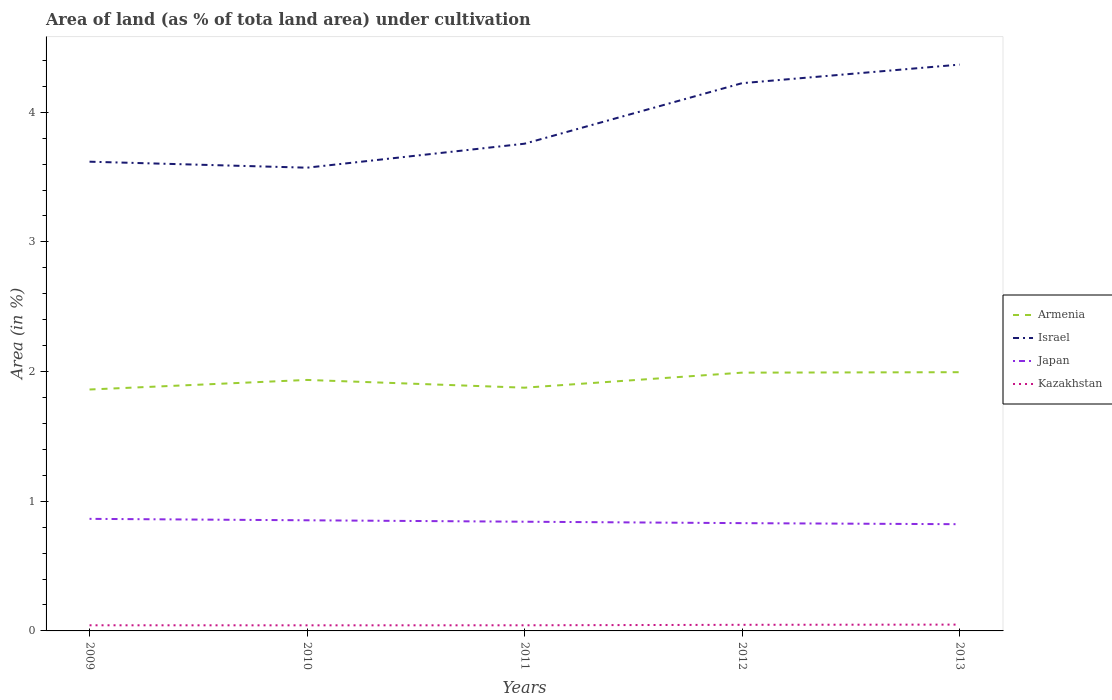Across all years, what is the maximum percentage of land under cultivation in Armenia?
Offer a terse response. 1.86. What is the total percentage of land under cultivation in Israel in the graph?
Provide a short and direct response. -0.61. What is the difference between the highest and the second highest percentage of land under cultivation in Japan?
Make the answer very short. 0.04. What is the difference between two consecutive major ticks on the Y-axis?
Offer a very short reply. 1. Are the values on the major ticks of Y-axis written in scientific E-notation?
Your answer should be compact. No. Does the graph contain any zero values?
Offer a very short reply. No. Does the graph contain grids?
Offer a terse response. No. How many legend labels are there?
Give a very brief answer. 4. What is the title of the graph?
Provide a short and direct response. Area of land (as % of tota land area) under cultivation. Does "United Arab Emirates" appear as one of the legend labels in the graph?
Your response must be concise. No. What is the label or title of the X-axis?
Your response must be concise. Years. What is the label or title of the Y-axis?
Your answer should be compact. Area (in %). What is the Area (in %) in Armenia in 2009?
Offer a very short reply. 1.86. What is the Area (in %) of Israel in 2009?
Give a very brief answer. 3.62. What is the Area (in %) in Japan in 2009?
Your answer should be compact. 0.86. What is the Area (in %) in Kazakhstan in 2009?
Offer a terse response. 0.04. What is the Area (in %) in Armenia in 2010?
Offer a terse response. 1.94. What is the Area (in %) in Israel in 2010?
Keep it short and to the point. 3.57. What is the Area (in %) in Japan in 2010?
Your answer should be compact. 0.85. What is the Area (in %) in Kazakhstan in 2010?
Your answer should be compact. 0.04. What is the Area (in %) in Armenia in 2011?
Your response must be concise. 1.88. What is the Area (in %) of Israel in 2011?
Ensure brevity in your answer.  3.76. What is the Area (in %) in Japan in 2011?
Provide a short and direct response. 0.84. What is the Area (in %) in Kazakhstan in 2011?
Provide a succinct answer. 0.04. What is the Area (in %) of Armenia in 2012?
Offer a terse response. 1.99. What is the Area (in %) in Israel in 2012?
Your response must be concise. 4.22. What is the Area (in %) of Japan in 2012?
Offer a terse response. 0.83. What is the Area (in %) in Kazakhstan in 2012?
Provide a succinct answer. 0.05. What is the Area (in %) in Armenia in 2013?
Ensure brevity in your answer.  2. What is the Area (in %) of Israel in 2013?
Provide a succinct answer. 4.37. What is the Area (in %) in Japan in 2013?
Provide a succinct answer. 0.82. What is the Area (in %) in Kazakhstan in 2013?
Provide a succinct answer. 0.05. Across all years, what is the maximum Area (in %) in Armenia?
Your answer should be compact. 2. Across all years, what is the maximum Area (in %) in Israel?
Make the answer very short. 4.37. Across all years, what is the maximum Area (in %) in Japan?
Keep it short and to the point. 0.86. Across all years, what is the maximum Area (in %) of Kazakhstan?
Your answer should be compact. 0.05. Across all years, what is the minimum Area (in %) of Armenia?
Keep it short and to the point. 1.86. Across all years, what is the minimum Area (in %) in Israel?
Keep it short and to the point. 3.57. Across all years, what is the minimum Area (in %) in Japan?
Ensure brevity in your answer.  0.82. Across all years, what is the minimum Area (in %) of Kazakhstan?
Your response must be concise. 0.04. What is the total Area (in %) in Armenia in the graph?
Your response must be concise. 9.66. What is the total Area (in %) in Israel in the graph?
Make the answer very short. 19.54. What is the total Area (in %) in Japan in the graph?
Provide a short and direct response. 4.21. What is the total Area (in %) of Kazakhstan in the graph?
Offer a terse response. 0.23. What is the difference between the Area (in %) of Armenia in 2009 and that in 2010?
Ensure brevity in your answer.  -0.07. What is the difference between the Area (in %) of Israel in 2009 and that in 2010?
Your response must be concise. 0.05. What is the difference between the Area (in %) of Japan in 2009 and that in 2010?
Offer a terse response. 0.01. What is the difference between the Area (in %) of Armenia in 2009 and that in 2011?
Provide a succinct answer. -0.01. What is the difference between the Area (in %) of Israel in 2009 and that in 2011?
Your answer should be very brief. -0.14. What is the difference between the Area (in %) in Japan in 2009 and that in 2011?
Offer a very short reply. 0.02. What is the difference between the Area (in %) in Kazakhstan in 2009 and that in 2011?
Offer a terse response. 0. What is the difference between the Area (in %) in Armenia in 2009 and that in 2012?
Provide a short and direct response. -0.13. What is the difference between the Area (in %) in Israel in 2009 and that in 2012?
Ensure brevity in your answer.  -0.61. What is the difference between the Area (in %) in Japan in 2009 and that in 2012?
Your answer should be very brief. 0.03. What is the difference between the Area (in %) of Kazakhstan in 2009 and that in 2012?
Offer a very short reply. -0. What is the difference between the Area (in %) in Armenia in 2009 and that in 2013?
Provide a short and direct response. -0.13. What is the difference between the Area (in %) in Israel in 2009 and that in 2013?
Make the answer very short. -0.75. What is the difference between the Area (in %) of Japan in 2009 and that in 2013?
Provide a short and direct response. 0.04. What is the difference between the Area (in %) in Kazakhstan in 2009 and that in 2013?
Provide a succinct answer. -0.01. What is the difference between the Area (in %) of Armenia in 2010 and that in 2011?
Offer a terse response. 0.06. What is the difference between the Area (in %) in Israel in 2010 and that in 2011?
Offer a terse response. -0.18. What is the difference between the Area (in %) in Japan in 2010 and that in 2011?
Your answer should be very brief. 0.01. What is the difference between the Area (in %) of Kazakhstan in 2010 and that in 2011?
Your answer should be compact. -0. What is the difference between the Area (in %) of Armenia in 2010 and that in 2012?
Ensure brevity in your answer.  -0.06. What is the difference between the Area (in %) of Israel in 2010 and that in 2012?
Keep it short and to the point. -0.65. What is the difference between the Area (in %) in Japan in 2010 and that in 2012?
Keep it short and to the point. 0.02. What is the difference between the Area (in %) in Kazakhstan in 2010 and that in 2012?
Keep it short and to the point. -0. What is the difference between the Area (in %) of Armenia in 2010 and that in 2013?
Your answer should be compact. -0.06. What is the difference between the Area (in %) in Israel in 2010 and that in 2013?
Your answer should be very brief. -0.79. What is the difference between the Area (in %) of Japan in 2010 and that in 2013?
Ensure brevity in your answer.  0.03. What is the difference between the Area (in %) of Kazakhstan in 2010 and that in 2013?
Offer a very short reply. -0.01. What is the difference between the Area (in %) in Armenia in 2011 and that in 2012?
Keep it short and to the point. -0.12. What is the difference between the Area (in %) of Israel in 2011 and that in 2012?
Provide a short and direct response. -0.47. What is the difference between the Area (in %) in Japan in 2011 and that in 2012?
Provide a short and direct response. 0.01. What is the difference between the Area (in %) in Kazakhstan in 2011 and that in 2012?
Offer a very short reply. -0. What is the difference between the Area (in %) in Armenia in 2011 and that in 2013?
Make the answer very short. -0.12. What is the difference between the Area (in %) in Israel in 2011 and that in 2013?
Offer a terse response. -0.61. What is the difference between the Area (in %) of Japan in 2011 and that in 2013?
Give a very brief answer. 0.02. What is the difference between the Area (in %) in Kazakhstan in 2011 and that in 2013?
Your answer should be compact. -0.01. What is the difference between the Area (in %) in Armenia in 2012 and that in 2013?
Provide a short and direct response. -0. What is the difference between the Area (in %) in Israel in 2012 and that in 2013?
Your answer should be compact. -0.14. What is the difference between the Area (in %) of Japan in 2012 and that in 2013?
Give a very brief answer. 0.01. What is the difference between the Area (in %) of Kazakhstan in 2012 and that in 2013?
Offer a very short reply. -0. What is the difference between the Area (in %) of Armenia in 2009 and the Area (in %) of Israel in 2010?
Offer a terse response. -1.71. What is the difference between the Area (in %) of Armenia in 2009 and the Area (in %) of Japan in 2010?
Provide a succinct answer. 1.01. What is the difference between the Area (in %) of Armenia in 2009 and the Area (in %) of Kazakhstan in 2010?
Ensure brevity in your answer.  1.82. What is the difference between the Area (in %) in Israel in 2009 and the Area (in %) in Japan in 2010?
Give a very brief answer. 2.77. What is the difference between the Area (in %) in Israel in 2009 and the Area (in %) in Kazakhstan in 2010?
Offer a very short reply. 3.58. What is the difference between the Area (in %) in Japan in 2009 and the Area (in %) in Kazakhstan in 2010?
Keep it short and to the point. 0.82. What is the difference between the Area (in %) of Armenia in 2009 and the Area (in %) of Israel in 2011?
Provide a succinct answer. -1.9. What is the difference between the Area (in %) of Armenia in 2009 and the Area (in %) of Japan in 2011?
Keep it short and to the point. 1.02. What is the difference between the Area (in %) of Armenia in 2009 and the Area (in %) of Kazakhstan in 2011?
Your answer should be very brief. 1.82. What is the difference between the Area (in %) in Israel in 2009 and the Area (in %) in Japan in 2011?
Your answer should be very brief. 2.78. What is the difference between the Area (in %) of Israel in 2009 and the Area (in %) of Kazakhstan in 2011?
Your answer should be compact. 3.57. What is the difference between the Area (in %) in Japan in 2009 and the Area (in %) in Kazakhstan in 2011?
Your answer should be very brief. 0.82. What is the difference between the Area (in %) of Armenia in 2009 and the Area (in %) of Israel in 2012?
Provide a succinct answer. -2.36. What is the difference between the Area (in %) in Armenia in 2009 and the Area (in %) in Japan in 2012?
Ensure brevity in your answer.  1.03. What is the difference between the Area (in %) of Armenia in 2009 and the Area (in %) of Kazakhstan in 2012?
Offer a terse response. 1.81. What is the difference between the Area (in %) in Israel in 2009 and the Area (in %) in Japan in 2012?
Keep it short and to the point. 2.79. What is the difference between the Area (in %) in Israel in 2009 and the Area (in %) in Kazakhstan in 2012?
Ensure brevity in your answer.  3.57. What is the difference between the Area (in %) of Japan in 2009 and the Area (in %) of Kazakhstan in 2012?
Give a very brief answer. 0.82. What is the difference between the Area (in %) in Armenia in 2009 and the Area (in %) in Israel in 2013?
Ensure brevity in your answer.  -2.51. What is the difference between the Area (in %) in Armenia in 2009 and the Area (in %) in Japan in 2013?
Provide a short and direct response. 1.04. What is the difference between the Area (in %) of Armenia in 2009 and the Area (in %) of Kazakhstan in 2013?
Your response must be concise. 1.81. What is the difference between the Area (in %) in Israel in 2009 and the Area (in %) in Japan in 2013?
Ensure brevity in your answer.  2.8. What is the difference between the Area (in %) in Israel in 2009 and the Area (in %) in Kazakhstan in 2013?
Provide a short and direct response. 3.57. What is the difference between the Area (in %) of Japan in 2009 and the Area (in %) of Kazakhstan in 2013?
Your answer should be compact. 0.82. What is the difference between the Area (in %) in Armenia in 2010 and the Area (in %) in Israel in 2011?
Your answer should be very brief. -1.82. What is the difference between the Area (in %) of Armenia in 2010 and the Area (in %) of Japan in 2011?
Offer a terse response. 1.09. What is the difference between the Area (in %) of Armenia in 2010 and the Area (in %) of Kazakhstan in 2011?
Your answer should be compact. 1.89. What is the difference between the Area (in %) in Israel in 2010 and the Area (in %) in Japan in 2011?
Offer a terse response. 2.73. What is the difference between the Area (in %) of Israel in 2010 and the Area (in %) of Kazakhstan in 2011?
Make the answer very short. 3.53. What is the difference between the Area (in %) in Japan in 2010 and the Area (in %) in Kazakhstan in 2011?
Offer a terse response. 0.81. What is the difference between the Area (in %) in Armenia in 2010 and the Area (in %) in Israel in 2012?
Your answer should be compact. -2.29. What is the difference between the Area (in %) of Armenia in 2010 and the Area (in %) of Japan in 2012?
Offer a very short reply. 1.1. What is the difference between the Area (in %) in Armenia in 2010 and the Area (in %) in Kazakhstan in 2012?
Give a very brief answer. 1.89. What is the difference between the Area (in %) of Israel in 2010 and the Area (in %) of Japan in 2012?
Give a very brief answer. 2.74. What is the difference between the Area (in %) of Israel in 2010 and the Area (in %) of Kazakhstan in 2012?
Give a very brief answer. 3.52. What is the difference between the Area (in %) of Japan in 2010 and the Area (in %) of Kazakhstan in 2012?
Provide a succinct answer. 0.81. What is the difference between the Area (in %) of Armenia in 2010 and the Area (in %) of Israel in 2013?
Make the answer very short. -2.43. What is the difference between the Area (in %) in Armenia in 2010 and the Area (in %) in Japan in 2013?
Offer a very short reply. 1.11. What is the difference between the Area (in %) of Armenia in 2010 and the Area (in %) of Kazakhstan in 2013?
Keep it short and to the point. 1.89. What is the difference between the Area (in %) in Israel in 2010 and the Area (in %) in Japan in 2013?
Your answer should be very brief. 2.75. What is the difference between the Area (in %) of Israel in 2010 and the Area (in %) of Kazakhstan in 2013?
Keep it short and to the point. 3.52. What is the difference between the Area (in %) in Japan in 2010 and the Area (in %) in Kazakhstan in 2013?
Make the answer very short. 0.8. What is the difference between the Area (in %) of Armenia in 2011 and the Area (in %) of Israel in 2012?
Provide a short and direct response. -2.35. What is the difference between the Area (in %) of Armenia in 2011 and the Area (in %) of Japan in 2012?
Offer a very short reply. 1.04. What is the difference between the Area (in %) of Armenia in 2011 and the Area (in %) of Kazakhstan in 2012?
Provide a short and direct response. 1.83. What is the difference between the Area (in %) in Israel in 2011 and the Area (in %) in Japan in 2012?
Provide a succinct answer. 2.93. What is the difference between the Area (in %) of Israel in 2011 and the Area (in %) of Kazakhstan in 2012?
Provide a short and direct response. 3.71. What is the difference between the Area (in %) of Japan in 2011 and the Area (in %) of Kazakhstan in 2012?
Your response must be concise. 0.8. What is the difference between the Area (in %) in Armenia in 2011 and the Area (in %) in Israel in 2013?
Your answer should be very brief. -2.49. What is the difference between the Area (in %) in Armenia in 2011 and the Area (in %) in Japan in 2013?
Your answer should be compact. 1.05. What is the difference between the Area (in %) of Armenia in 2011 and the Area (in %) of Kazakhstan in 2013?
Your response must be concise. 1.83. What is the difference between the Area (in %) in Israel in 2011 and the Area (in %) in Japan in 2013?
Your answer should be compact. 2.93. What is the difference between the Area (in %) of Israel in 2011 and the Area (in %) of Kazakhstan in 2013?
Keep it short and to the point. 3.71. What is the difference between the Area (in %) in Japan in 2011 and the Area (in %) in Kazakhstan in 2013?
Give a very brief answer. 0.79. What is the difference between the Area (in %) of Armenia in 2012 and the Area (in %) of Israel in 2013?
Provide a short and direct response. -2.38. What is the difference between the Area (in %) of Armenia in 2012 and the Area (in %) of Japan in 2013?
Give a very brief answer. 1.17. What is the difference between the Area (in %) of Armenia in 2012 and the Area (in %) of Kazakhstan in 2013?
Ensure brevity in your answer.  1.94. What is the difference between the Area (in %) in Israel in 2012 and the Area (in %) in Japan in 2013?
Offer a very short reply. 3.4. What is the difference between the Area (in %) of Israel in 2012 and the Area (in %) of Kazakhstan in 2013?
Offer a very short reply. 4.17. What is the difference between the Area (in %) in Japan in 2012 and the Area (in %) in Kazakhstan in 2013?
Your answer should be compact. 0.78. What is the average Area (in %) in Armenia per year?
Give a very brief answer. 1.93. What is the average Area (in %) of Israel per year?
Offer a terse response. 3.91. What is the average Area (in %) in Japan per year?
Provide a short and direct response. 0.84. What is the average Area (in %) of Kazakhstan per year?
Your answer should be very brief. 0.05. In the year 2009, what is the difference between the Area (in %) in Armenia and Area (in %) in Israel?
Ensure brevity in your answer.  -1.76. In the year 2009, what is the difference between the Area (in %) of Armenia and Area (in %) of Kazakhstan?
Provide a short and direct response. 1.82. In the year 2009, what is the difference between the Area (in %) in Israel and Area (in %) in Japan?
Make the answer very short. 2.75. In the year 2009, what is the difference between the Area (in %) in Israel and Area (in %) in Kazakhstan?
Provide a short and direct response. 3.57. In the year 2009, what is the difference between the Area (in %) of Japan and Area (in %) of Kazakhstan?
Keep it short and to the point. 0.82. In the year 2010, what is the difference between the Area (in %) of Armenia and Area (in %) of Israel?
Make the answer very short. -1.64. In the year 2010, what is the difference between the Area (in %) of Armenia and Area (in %) of Japan?
Offer a very short reply. 1.08. In the year 2010, what is the difference between the Area (in %) in Armenia and Area (in %) in Kazakhstan?
Keep it short and to the point. 1.89. In the year 2010, what is the difference between the Area (in %) in Israel and Area (in %) in Japan?
Keep it short and to the point. 2.72. In the year 2010, what is the difference between the Area (in %) of Israel and Area (in %) of Kazakhstan?
Provide a succinct answer. 3.53. In the year 2010, what is the difference between the Area (in %) in Japan and Area (in %) in Kazakhstan?
Your answer should be very brief. 0.81. In the year 2011, what is the difference between the Area (in %) of Armenia and Area (in %) of Israel?
Your answer should be compact. -1.88. In the year 2011, what is the difference between the Area (in %) of Armenia and Area (in %) of Japan?
Give a very brief answer. 1.03. In the year 2011, what is the difference between the Area (in %) of Armenia and Area (in %) of Kazakhstan?
Ensure brevity in your answer.  1.83. In the year 2011, what is the difference between the Area (in %) in Israel and Area (in %) in Japan?
Make the answer very short. 2.91. In the year 2011, what is the difference between the Area (in %) in Israel and Area (in %) in Kazakhstan?
Keep it short and to the point. 3.71. In the year 2011, what is the difference between the Area (in %) of Japan and Area (in %) of Kazakhstan?
Offer a very short reply. 0.8. In the year 2012, what is the difference between the Area (in %) of Armenia and Area (in %) of Israel?
Provide a short and direct response. -2.23. In the year 2012, what is the difference between the Area (in %) of Armenia and Area (in %) of Japan?
Keep it short and to the point. 1.16. In the year 2012, what is the difference between the Area (in %) of Armenia and Area (in %) of Kazakhstan?
Keep it short and to the point. 1.94. In the year 2012, what is the difference between the Area (in %) in Israel and Area (in %) in Japan?
Give a very brief answer. 3.39. In the year 2012, what is the difference between the Area (in %) of Israel and Area (in %) of Kazakhstan?
Offer a very short reply. 4.18. In the year 2012, what is the difference between the Area (in %) of Japan and Area (in %) of Kazakhstan?
Your response must be concise. 0.78. In the year 2013, what is the difference between the Area (in %) in Armenia and Area (in %) in Israel?
Keep it short and to the point. -2.37. In the year 2013, what is the difference between the Area (in %) of Armenia and Area (in %) of Japan?
Your response must be concise. 1.17. In the year 2013, what is the difference between the Area (in %) of Armenia and Area (in %) of Kazakhstan?
Ensure brevity in your answer.  1.95. In the year 2013, what is the difference between the Area (in %) of Israel and Area (in %) of Japan?
Offer a terse response. 3.54. In the year 2013, what is the difference between the Area (in %) in Israel and Area (in %) in Kazakhstan?
Your answer should be compact. 4.32. In the year 2013, what is the difference between the Area (in %) of Japan and Area (in %) of Kazakhstan?
Offer a very short reply. 0.77. What is the ratio of the Area (in %) of Armenia in 2009 to that in 2010?
Your answer should be very brief. 0.96. What is the ratio of the Area (in %) in Israel in 2009 to that in 2010?
Your answer should be very brief. 1.01. What is the ratio of the Area (in %) in Japan in 2009 to that in 2010?
Ensure brevity in your answer.  1.01. What is the ratio of the Area (in %) in Kazakhstan in 2009 to that in 2010?
Your response must be concise. 1.01. What is the ratio of the Area (in %) of Israel in 2009 to that in 2011?
Give a very brief answer. 0.96. What is the ratio of the Area (in %) of Japan in 2009 to that in 2011?
Make the answer very short. 1.03. What is the ratio of the Area (in %) in Kazakhstan in 2009 to that in 2011?
Keep it short and to the point. 1. What is the ratio of the Area (in %) of Armenia in 2009 to that in 2012?
Offer a terse response. 0.93. What is the ratio of the Area (in %) in Israel in 2009 to that in 2012?
Offer a terse response. 0.86. What is the ratio of the Area (in %) of Japan in 2009 to that in 2012?
Your answer should be very brief. 1.04. What is the ratio of the Area (in %) in Kazakhstan in 2009 to that in 2012?
Provide a succinct answer. 0.92. What is the ratio of the Area (in %) in Armenia in 2009 to that in 2013?
Give a very brief answer. 0.93. What is the ratio of the Area (in %) in Israel in 2009 to that in 2013?
Offer a very short reply. 0.83. What is the ratio of the Area (in %) of Japan in 2009 to that in 2013?
Provide a short and direct response. 1.05. What is the ratio of the Area (in %) of Kazakhstan in 2009 to that in 2013?
Ensure brevity in your answer.  0.89. What is the ratio of the Area (in %) in Armenia in 2010 to that in 2011?
Your answer should be compact. 1.03. What is the ratio of the Area (in %) in Israel in 2010 to that in 2011?
Your answer should be very brief. 0.95. What is the ratio of the Area (in %) in Armenia in 2010 to that in 2012?
Your answer should be very brief. 0.97. What is the ratio of the Area (in %) in Israel in 2010 to that in 2012?
Offer a very short reply. 0.85. What is the ratio of the Area (in %) in Japan in 2010 to that in 2012?
Provide a short and direct response. 1.03. What is the ratio of the Area (in %) of Kazakhstan in 2010 to that in 2012?
Offer a very short reply. 0.91. What is the ratio of the Area (in %) of Armenia in 2010 to that in 2013?
Keep it short and to the point. 0.97. What is the ratio of the Area (in %) of Israel in 2010 to that in 2013?
Provide a succinct answer. 0.82. What is the ratio of the Area (in %) in Japan in 2010 to that in 2013?
Your response must be concise. 1.04. What is the ratio of the Area (in %) of Kazakhstan in 2010 to that in 2013?
Offer a terse response. 0.88. What is the ratio of the Area (in %) in Armenia in 2011 to that in 2012?
Make the answer very short. 0.94. What is the ratio of the Area (in %) in Israel in 2011 to that in 2012?
Your answer should be compact. 0.89. What is the ratio of the Area (in %) of Japan in 2011 to that in 2012?
Offer a very short reply. 1.01. What is the ratio of the Area (in %) in Kazakhstan in 2011 to that in 2012?
Your answer should be very brief. 0.92. What is the ratio of the Area (in %) in Armenia in 2011 to that in 2013?
Make the answer very short. 0.94. What is the ratio of the Area (in %) of Israel in 2011 to that in 2013?
Make the answer very short. 0.86. What is the ratio of the Area (in %) of Japan in 2011 to that in 2013?
Your answer should be compact. 1.02. What is the ratio of the Area (in %) in Kazakhstan in 2011 to that in 2013?
Offer a terse response. 0.89. What is the ratio of the Area (in %) of Armenia in 2012 to that in 2013?
Provide a succinct answer. 1. What is the ratio of the Area (in %) of Israel in 2012 to that in 2013?
Your answer should be compact. 0.97. What is the ratio of the Area (in %) in Japan in 2012 to that in 2013?
Your answer should be compact. 1.01. What is the ratio of the Area (in %) of Kazakhstan in 2012 to that in 2013?
Your answer should be compact. 0.97. What is the difference between the highest and the second highest Area (in %) of Armenia?
Your answer should be very brief. 0. What is the difference between the highest and the second highest Area (in %) of Israel?
Make the answer very short. 0.14. What is the difference between the highest and the second highest Area (in %) of Japan?
Offer a terse response. 0.01. What is the difference between the highest and the second highest Area (in %) of Kazakhstan?
Offer a very short reply. 0. What is the difference between the highest and the lowest Area (in %) of Armenia?
Your answer should be very brief. 0.13. What is the difference between the highest and the lowest Area (in %) of Israel?
Provide a succinct answer. 0.79. What is the difference between the highest and the lowest Area (in %) in Japan?
Your answer should be compact. 0.04. What is the difference between the highest and the lowest Area (in %) of Kazakhstan?
Keep it short and to the point. 0.01. 